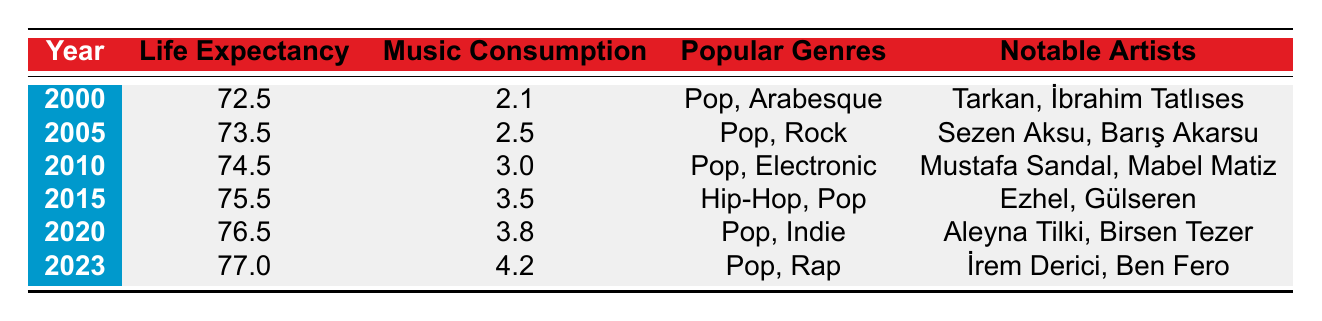What was the average life expectancy in 2010? The table shows the average life expectancy in the year 2010 is 74.5. You can find this information directly in the row corresponding to the year 2010.
Answer: 74.5 What was the music consumption per capita in 2023? According to the table, the music consumption per capita in 2023 is 4.2. This value is located in the row for the year 2023.
Answer: 4.2 Which year had the highest average life expectancy? Looking at the table, the year with the highest average life expectancy is 2023 with a value of 77.0. This can be found by comparing all the average life expectancy values across the years listed.
Answer: 2023 Is the average life expectancy increasing over the years? Yes, by examining the average life expectancy values from the years provided in the table, we see a consistent increase from 72.5 in 2000 to 77.0 in 2023. This indicates a trend of rising life expectancy over time.
Answer: Yes What is the difference in life expectancy between 2000 and 2020? To find the difference, subtract the average life expectancy in 2000 (72.5) from that in 2020 (76.5). Thus, 76.5 - 72.5 = 4.0. This shows a significant increase in life expectancy over this period.
Answer: 4.0 Which musical genre was popular in 2015? According to the table, the popular genres in 2015 were Hip-Hop and Pop, as stated in the row for that year.
Answer: Hip-Hop, Pop What was the average music consumption per capita from 2000 to 2023? To find the average, we add the music consumption values (2.1 + 2.5 + 3.0 + 3.5 + 3.8 + 4.2) = 19.1. There are 6 years in total, so the average is 19.1 divided by 6, which equals approximately 3.18. Thus, the average music consumption per capita during this period is about 3.18.
Answer: 3.18 Did the notable artists change over the years? Yes, by looking at the notable artists listed in the table, we can see that different artists were popular in different years. Each year's row features a different set of artists, indicating changes in the music scene over time.
Answer: Yes Which year experienced a rise in both life expectancy and music consumption? By examining the table, we can see that all years displayed an increase in both average life expectancy and music consumption. To find any particular year, we can check a few examples: 2000 to 2005, and 2015 to 2020 both show increases in both metrics.
Answer: All years experienced a rise 